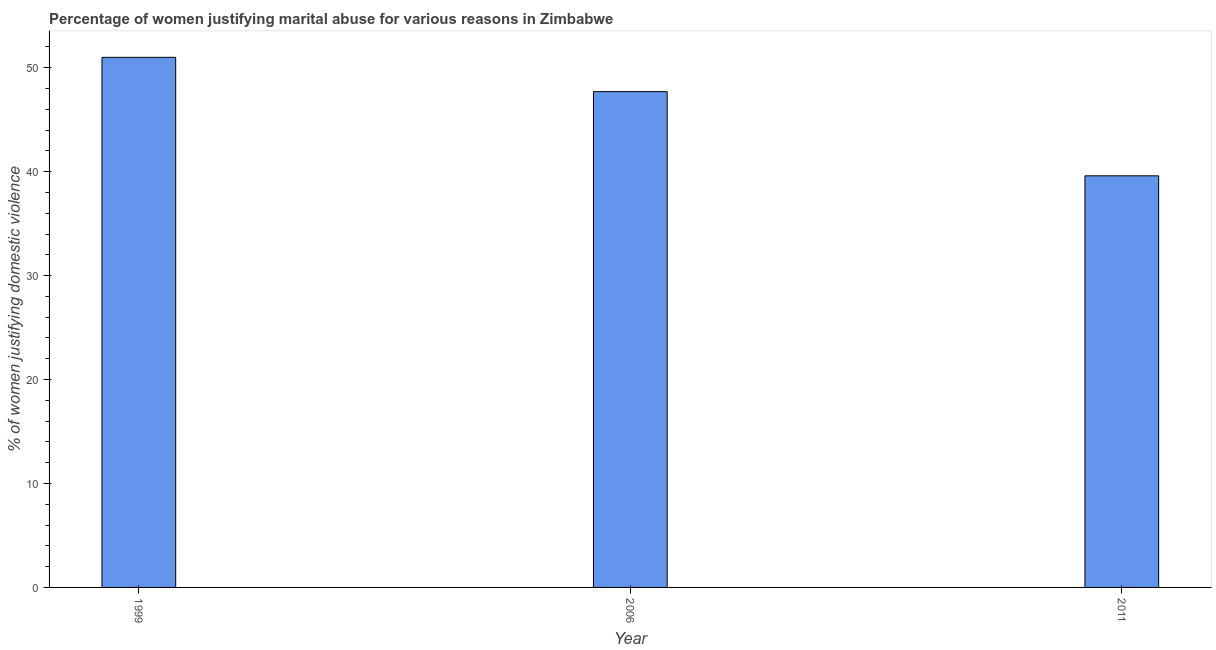Does the graph contain any zero values?
Ensure brevity in your answer.  No. Does the graph contain grids?
Ensure brevity in your answer.  No. What is the title of the graph?
Your answer should be very brief. Percentage of women justifying marital abuse for various reasons in Zimbabwe. What is the label or title of the X-axis?
Offer a terse response. Year. What is the label or title of the Y-axis?
Provide a succinct answer. % of women justifying domestic violence. What is the percentage of women justifying marital abuse in 2006?
Offer a terse response. 47.7. Across all years, what is the minimum percentage of women justifying marital abuse?
Keep it short and to the point. 39.6. In which year was the percentage of women justifying marital abuse maximum?
Give a very brief answer. 1999. What is the sum of the percentage of women justifying marital abuse?
Keep it short and to the point. 138.3. What is the average percentage of women justifying marital abuse per year?
Make the answer very short. 46.1. What is the median percentage of women justifying marital abuse?
Provide a succinct answer. 47.7. In how many years, is the percentage of women justifying marital abuse greater than 26 %?
Keep it short and to the point. 3. Do a majority of the years between 1999 and 2011 (inclusive) have percentage of women justifying marital abuse greater than 2 %?
Your response must be concise. Yes. What is the ratio of the percentage of women justifying marital abuse in 1999 to that in 2006?
Your answer should be compact. 1.07. Is the difference between the percentage of women justifying marital abuse in 1999 and 2011 greater than the difference between any two years?
Your answer should be compact. Yes. Is the sum of the percentage of women justifying marital abuse in 2006 and 2011 greater than the maximum percentage of women justifying marital abuse across all years?
Ensure brevity in your answer.  Yes. How many bars are there?
Keep it short and to the point. 3. Are all the bars in the graph horizontal?
Provide a short and direct response. No. How many years are there in the graph?
Make the answer very short. 3. What is the difference between two consecutive major ticks on the Y-axis?
Ensure brevity in your answer.  10. Are the values on the major ticks of Y-axis written in scientific E-notation?
Keep it short and to the point. No. What is the % of women justifying domestic violence of 1999?
Provide a short and direct response. 51. What is the % of women justifying domestic violence in 2006?
Give a very brief answer. 47.7. What is the % of women justifying domestic violence of 2011?
Your response must be concise. 39.6. What is the difference between the % of women justifying domestic violence in 1999 and 2006?
Your answer should be very brief. 3.3. What is the difference between the % of women justifying domestic violence in 1999 and 2011?
Ensure brevity in your answer.  11.4. What is the ratio of the % of women justifying domestic violence in 1999 to that in 2006?
Provide a short and direct response. 1.07. What is the ratio of the % of women justifying domestic violence in 1999 to that in 2011?
Your answer should be very brief. 1.29. What is the ratio of the % of women justifying domestic violence in 2006 to that in 2011?
Offer a very short reply. 1.21. 